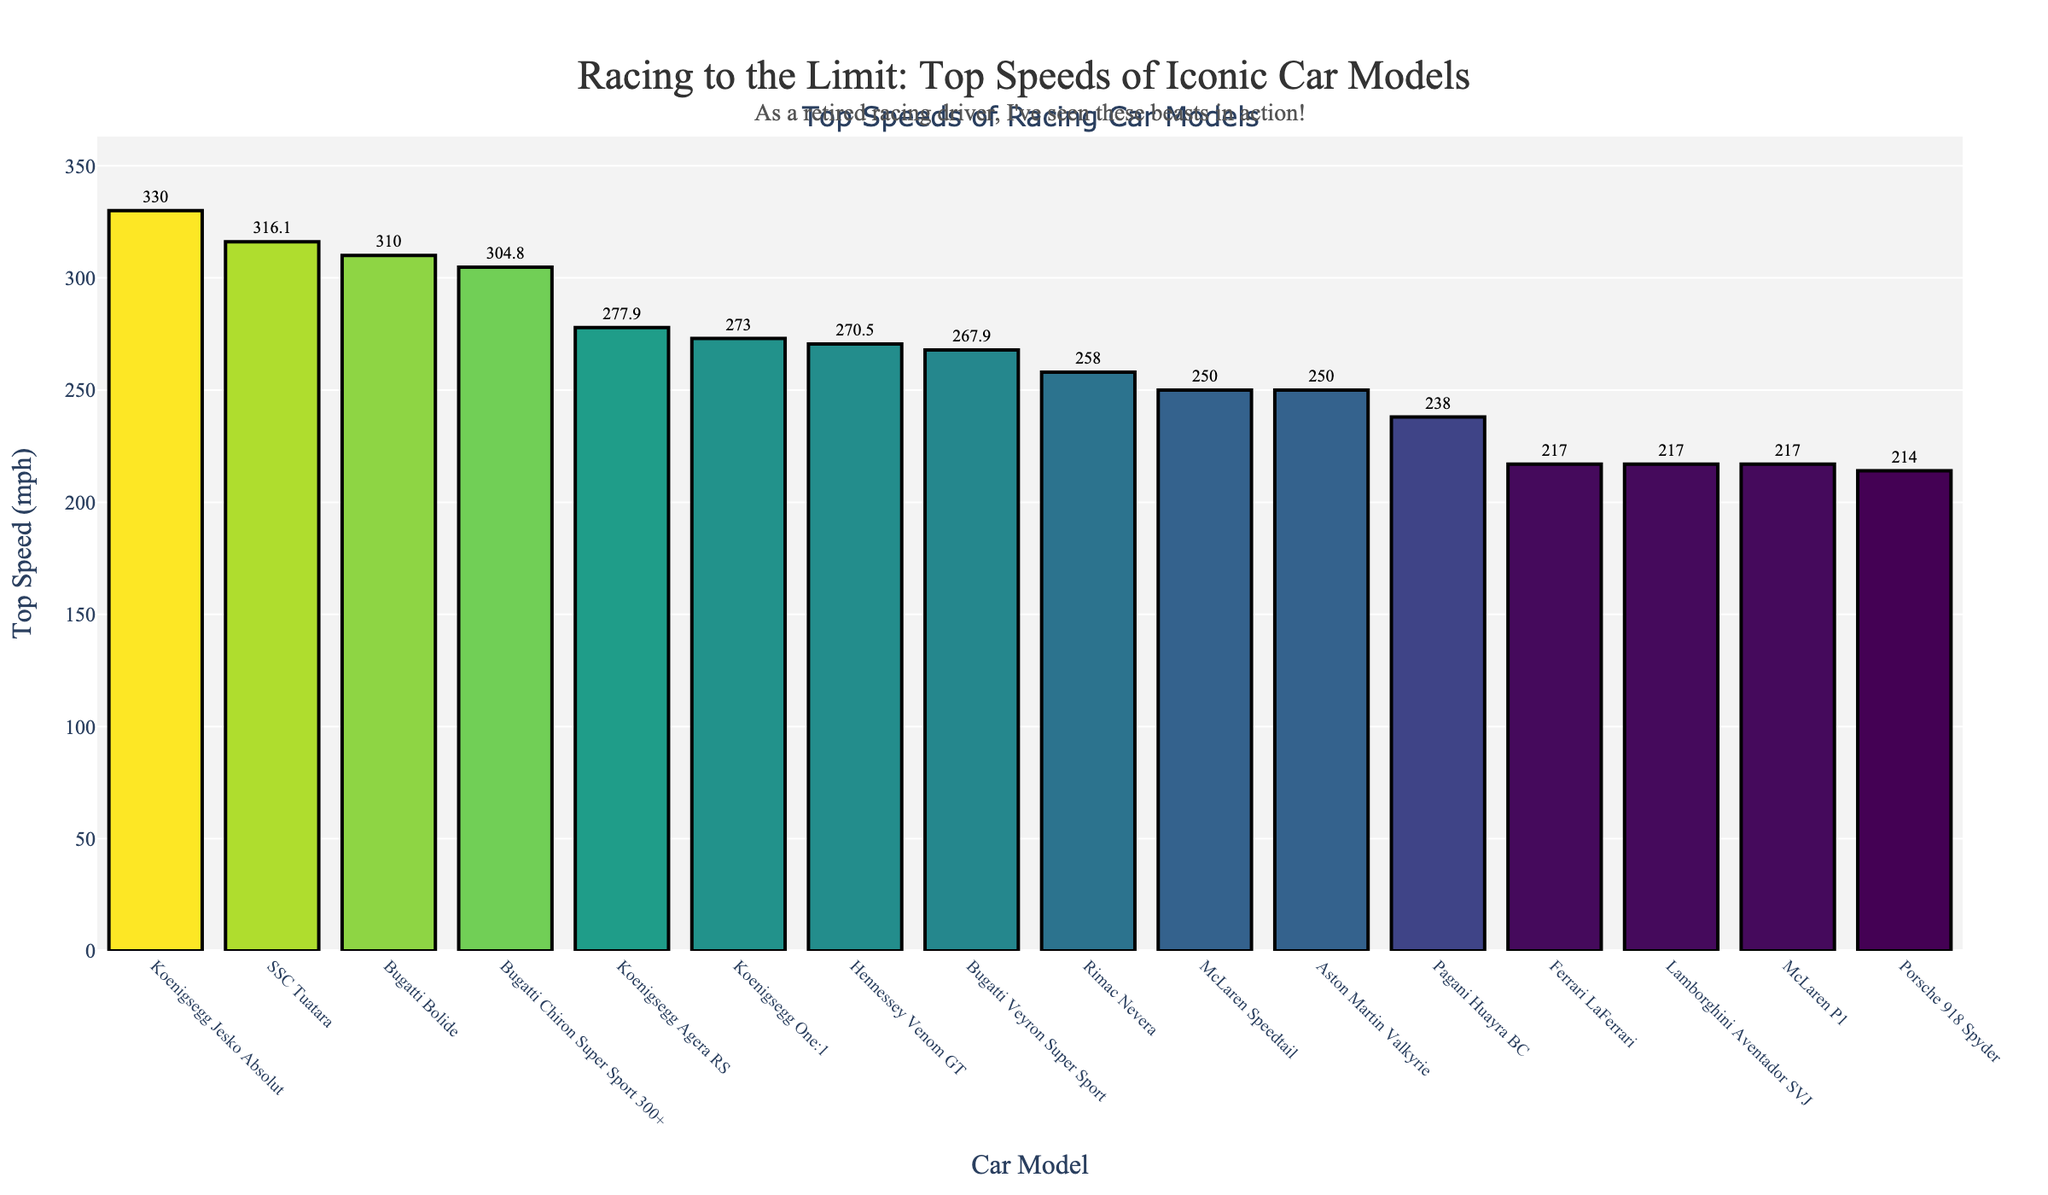What is the top speed of the fastest car? The fastest car on the chart is the Koenigsegg Jesko Absolut with a top speed of 330 mph, as seen from the highest bar in the chart.
Answer: 330 mph Which car model has a slightly higher top speed than the Bugatti Bolide? The SSC Tuatara has a slightly higher top speed than the Bugatti Bolide, as their respective speeds are 316.11 mph for SSC Tuatara and 310.0 mph for Bugatti Bolide.
Answer: SSC Tuatara How many cars have a top speed greater than 250 mph? Count the bars representing speeds greater than 250 mph: Bugatti Chiron Super Sport 300+, Koenigsegg Agera RS, Hennessey Venom GT, Bugatti Veyron Super Sport, SSC Tuatara, Koenigsegg Jesko Absolut, Bugatti Bolide, Rimac Nevera, and Koenigsegg One:1. There are 9 cars in total.
Answer: 9 What is the difference in top speed between the Bugatti Veyron Super Sport and the McLaren Speedtail? The Bugatti Veyron Super Sport has a top speed of 267.856 mph, and the McLaren Speedtail has a top speed of 250.0 mph. The difference is calculated as 267.856 - 250.0 = 17.856 mph.
Answer: 17.856 mph Which car models have the same top speed of 217 mph? The car models with the same top speed of 217 mph are the Ferrari LaFerrari, Lamborghini Aventador SVJ, and McLaren P1, as indicated by the bars of equal height marked with this speed.
Answer: Ferrari LaFerrari, Lamborghini Aventador SVJ, McLaren P1 How does the top speed of the Porsche 918 Spyder compare to the average top speed of the cars shown? Calculate the average top speed first: Add up all the top speeds (304.77 + 277.87 + 270.49 + 267.856 + 316.11 + 330 + 250 + 310 + 250 + 258 + 214 + 217 + 217 + 238 + 217 + 273) = 4211.096. Divide by the number of cars (16), giving an average of 263.1935 mph. The Porsche 918 Spyder has a top speed of 214 mph, which is 263.1935 - 214 = 49.1935 mph lower than the average.
Answer: 49.1935 mph lower What is the combined top speed of all Bugatti models shown? The top speeds of the Bugatti models are: Chiron Super Sport 300+ (304.77), Veyron Super Sport (267.856), and Bolide (310). Summing these speeds: 304.77 + 267.856 + 310 = 882.626 mph.
Answer: 882.626 mph Which car model has the lowest top speed, and what is its top speed? The bar representing the Porsche 918 Spyder is the shortest on the chart, indicating it has the lowest top speed, which is 214 mph.
Answer: Porsche 918 Spyder, 214 mph 